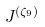<formula> <loc_0><loc_0><loc_500><loc_500>J ^ { ( \zeta _ { 9 } ) }</formula> 